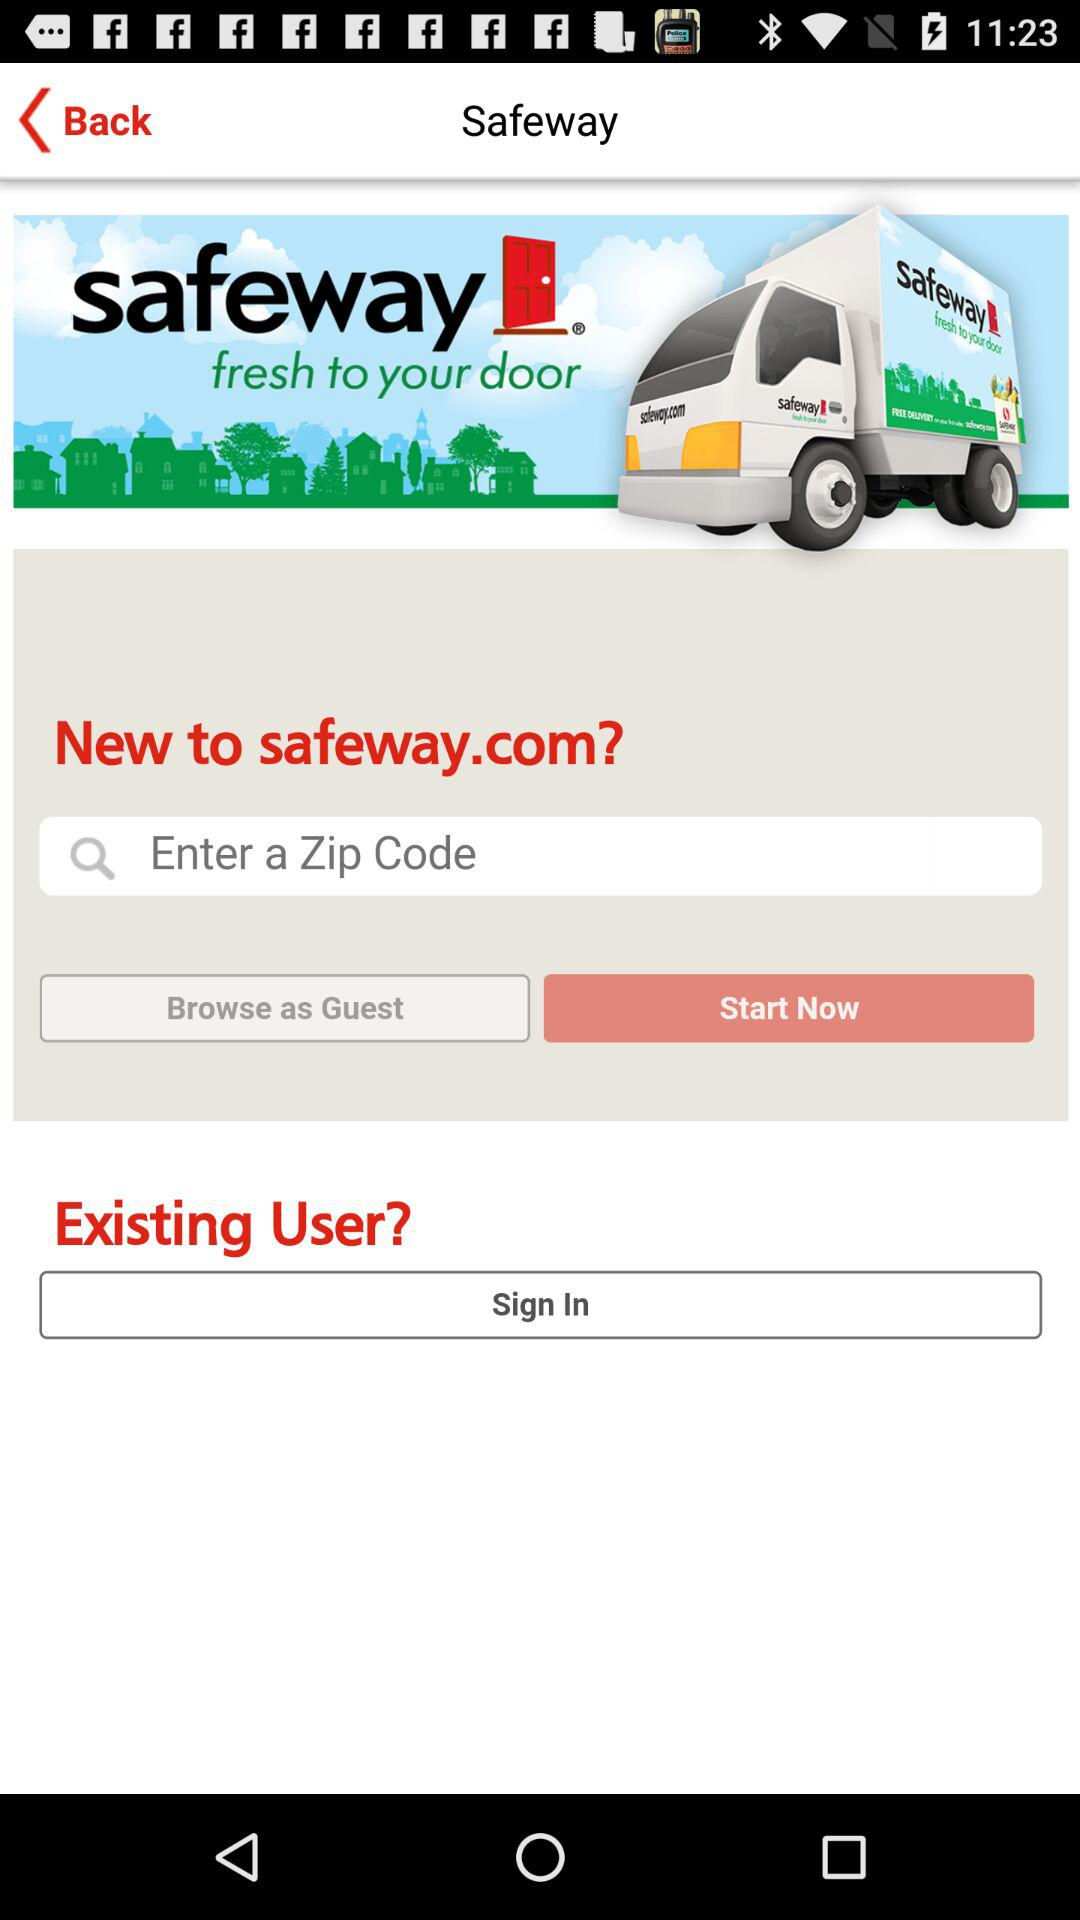What is the app title? The app title is "Safeway". 